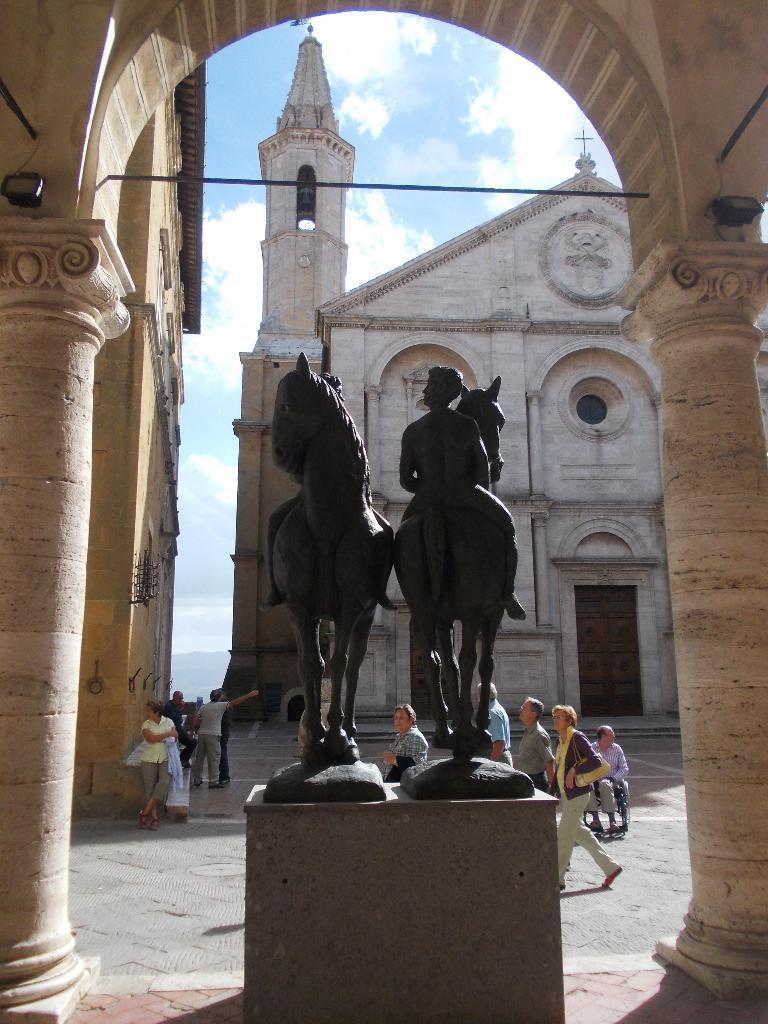Describe this image in one or two sentences. In this image I can see a black color statue. Few people are walking. Back I can see a building which is in cream color. The sky is in white and blue color. 